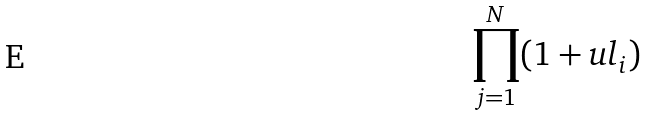Convert formula to latex. <formula><loc_0><loc_0><loc_500><loc_500>\prod _ { j = 1 } ^ { N } ( 1 + u l _ { i } )</formula> 